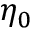Convert formula to latex. <formula><loc_0><loc_0><loc_500><loc_500>\eta _ { 0 }</formula> 